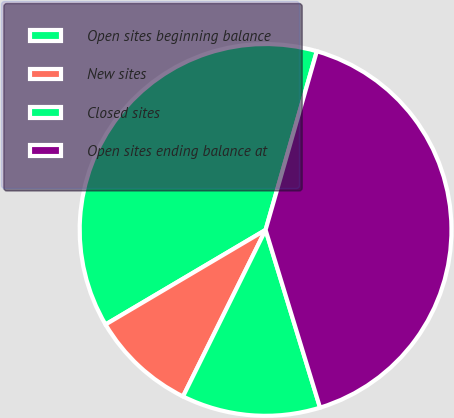Convert chart. <chart><loc_0><loc_0><loc_500><loc_500><pie_chart><fcel>Open sites beginning balance<fcel>New sites<fcel>Closed sites<fcel>Open sites ending balance at<nl><fcel>37.94%<fcel>9.18%<fcel>12.06%<fcel>40.82%<nl></chart> 